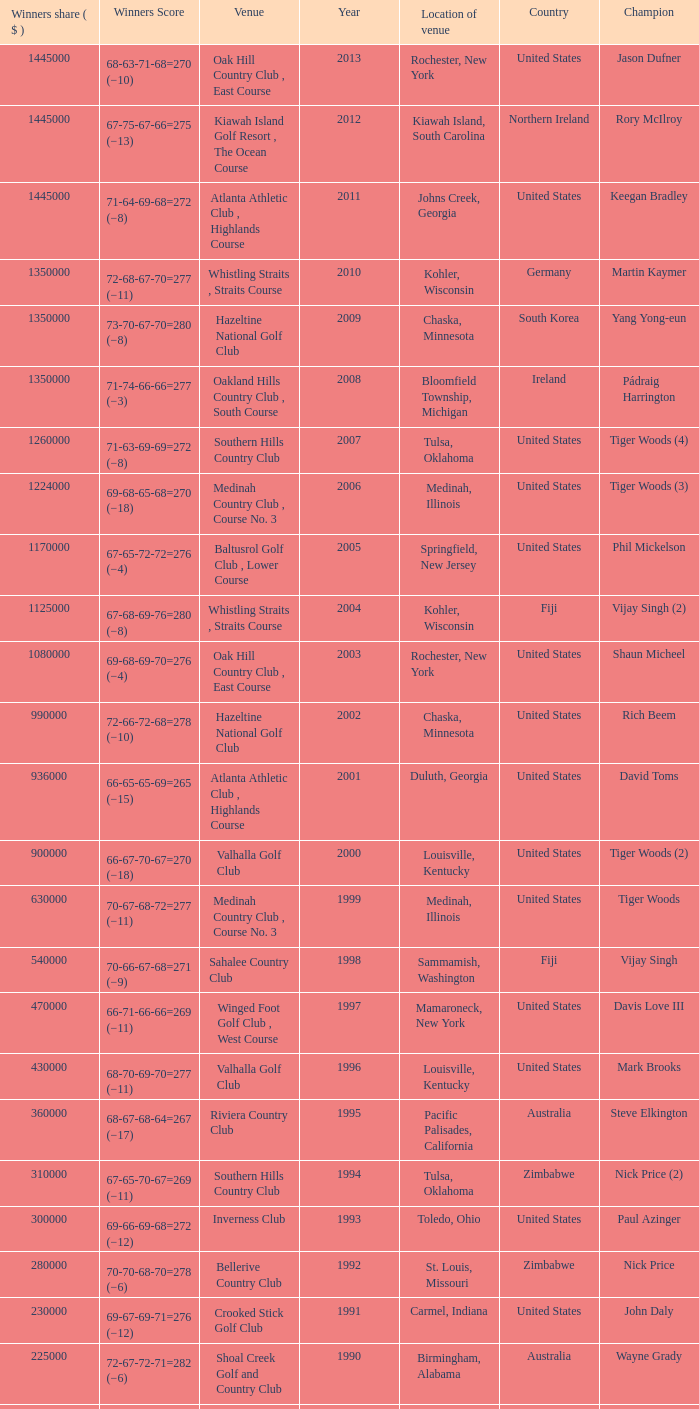Where is the Bellerive Country Club venue located? St. Louis, Missouri. 